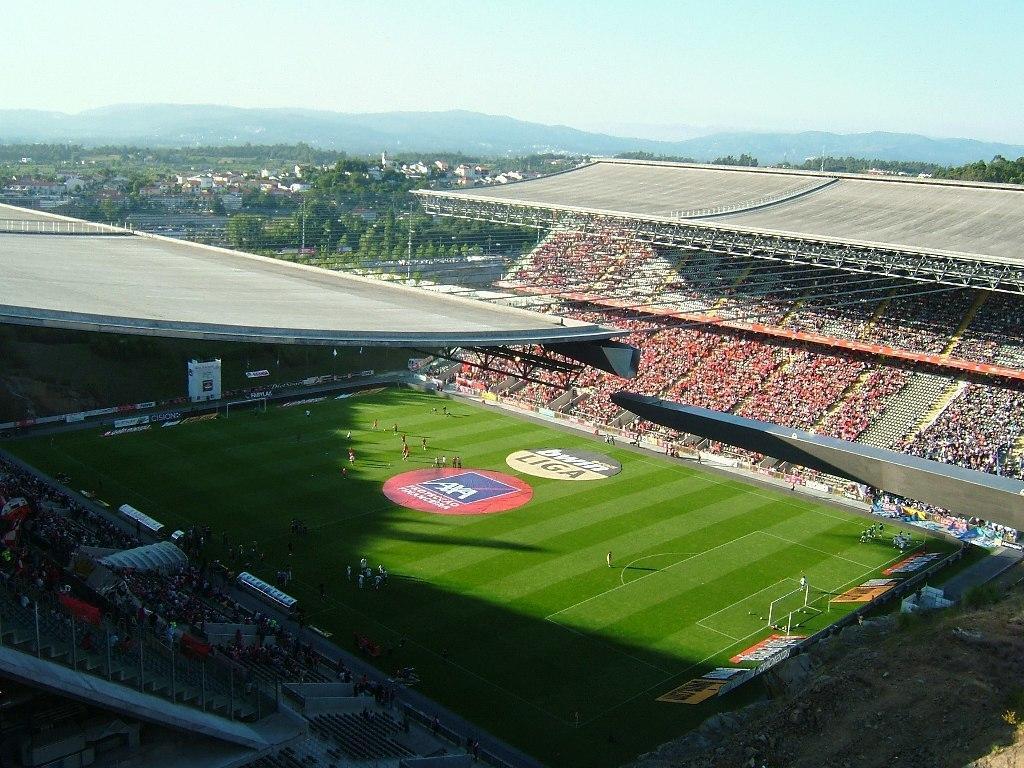Please provide a concise description of this image. Picture of a stadium. Here we can see people, hoardings, open-sheds and grass. Background we can see trees, buildings, mountains and sky. 